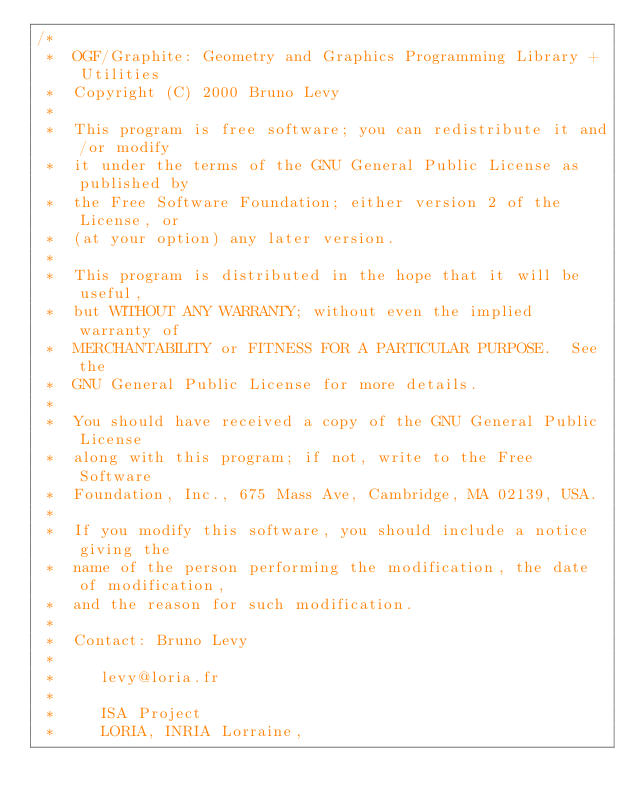Convert code to text. <code><loc_0><loc_0><loc_500><loc_500><_C++_>/*
 *  OGF/Graphite: Geometry and Graphics Programming Library + Utilities
 *  Copyright (C) 2000 Bruno Levy
 *
 *  This program is free software; you can redistribute it and/or modify
 *  it under the terms of the GNU General Public License as published by
 *  the Free Software Foundation; either version 2 of the License, or
 *  (at your option) any later version.
 *
 *  This program is distributed in the hope that it will be useful,
 *  but WITHOUT ANY WARRANTY; without even the implied warranty of
 *  MERCHANTABILITY or FITNESS FOR A PARTICULAR PURPOSE.  See the
 *  GNU General Public License for more details.
 *
 *  You should have received a copy of the GNU General Public License
 *  along with this program; if not, write to the Free Software
 *  Foundation, Inc., 675 Mass Ave, Cambridge, MA 02139, USA.
 *
 *  If you modify this software, you should include a notice giving the
 *  name of the person performing the modification, the date of modification,
 *  and the reason for such modification.
 *
 *  Contact: Bruno Levy
 *
 *     levy@loria.fr
 *
 *     ISA Project
 *     LORIA, INRIA Lorraine, </code> 